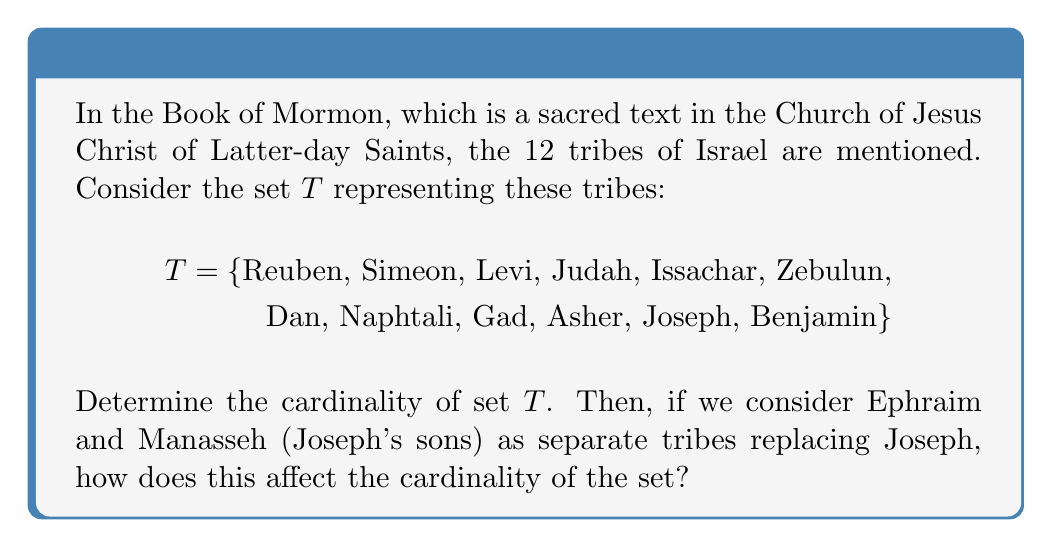What is the answer to this math problem? Let's approach this step-by-step:

1) First, we need to understand what cardinality means. The cardinality of a set is the number of elements in the set.

2) For the initial set $T$, we can simply count the number of elements:
   $$|T| = |\{\text{Reuben, Simeon, Levi, Judah, Issachar, Zebulun, Dan, Naphtali, Gad, Asher, Joseph, Benjamin}\}| = 12$$

3) Now, let's consider the case where Ephraim and Manasseh replace Joseph. We can call this new set $T'$:
   $$T' = \{\text{Reuben, Simeon, Levi, Judah, Issachar, Zebulun, Dan, Naphtali, Gad, Asher, Ephraim, Manasseh, Benjamin}\}$$

4) To find the cardinality of $T'$, we again count the elements:
   $$|T'| = 13$$

5) The cardinality increased by 1 because we removed 1 element (Joseph) and added 2 elements (Ephraim and Manasseh).
Answer: $|T| = 12$, $|T'| = 13$ 